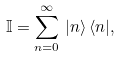Convert formula to latex. <formula><loc_0><loc_0><loc_500><loc_500>\mathbb { I } = \sum _ { n = 0 } ^ { \infty } \, | n \rangle \, \langle n | ,</formula> 